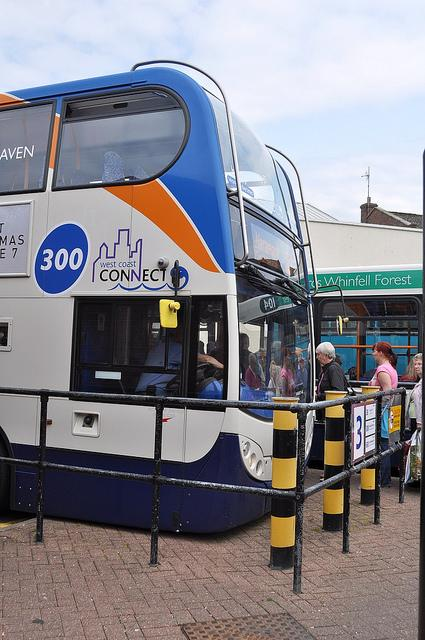The bus in the background is going to the home of which endangered animal? red squirrel 